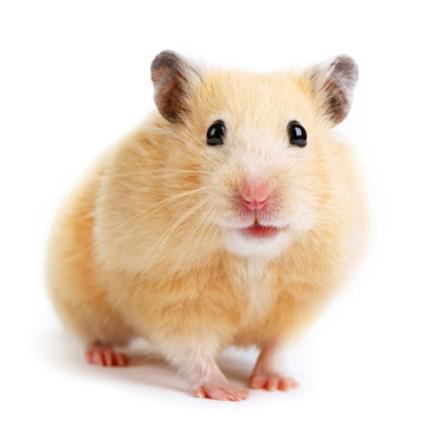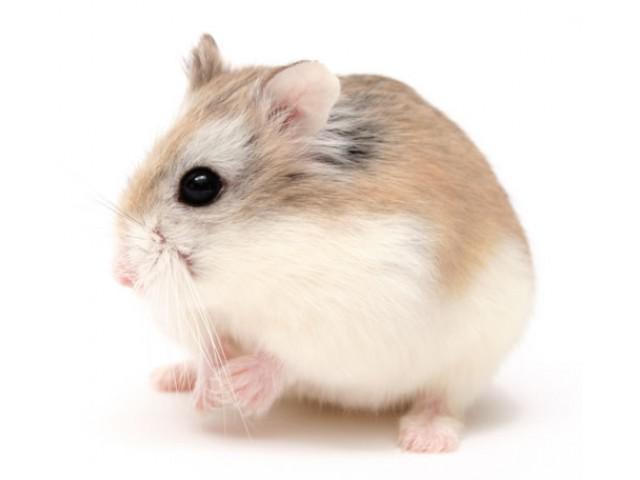The first image is the image on the left, the second image is the image on the right. Considering the images on both sides, is "In one of the images there are two hamsters." valid? Answer yes or no. No. 